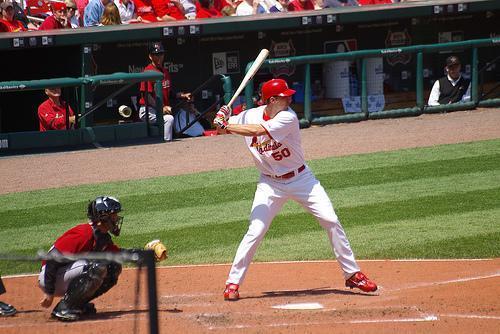How many bats are pictured?
Give a very brief answer. 1. How many players are holding a baseball bat?
Give a very brief answer. 1. 